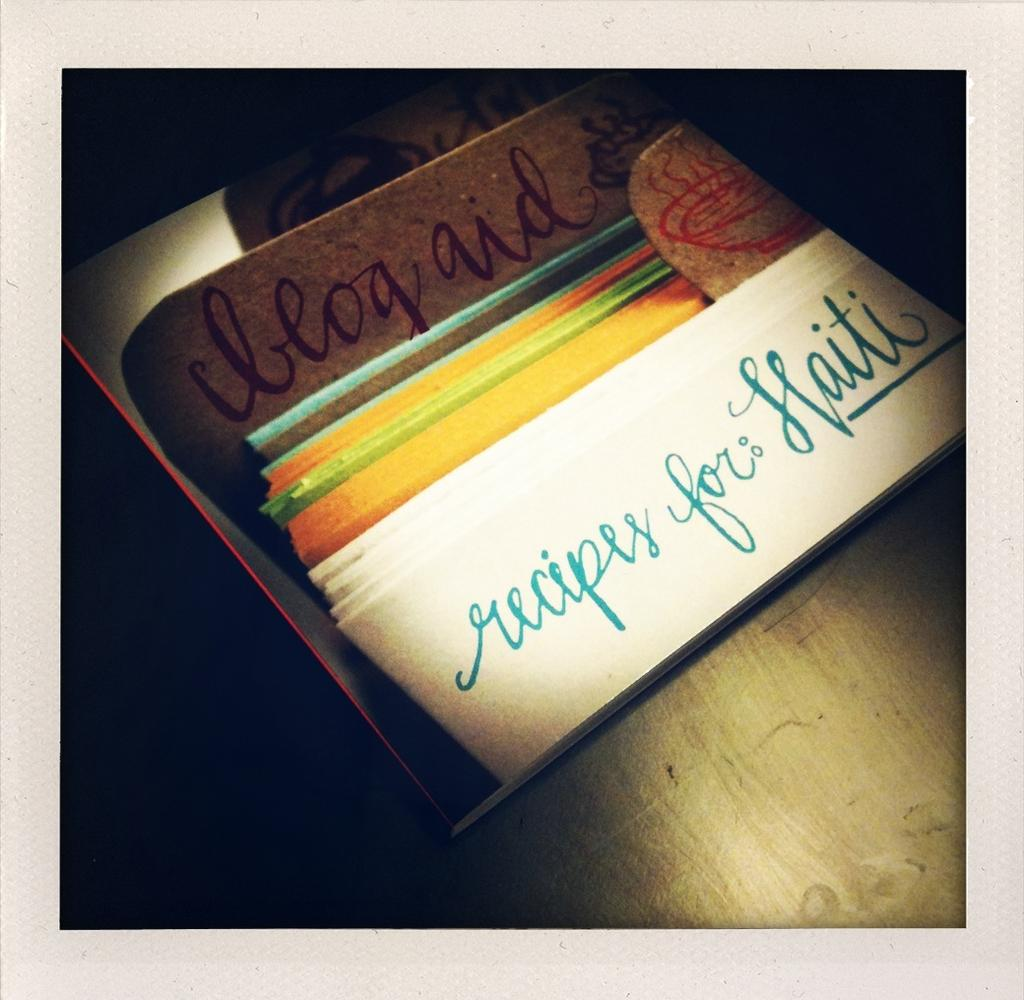<image>
Write a terse but informative summary of the picture. A recipe collection which includes recipes for flaiti. 